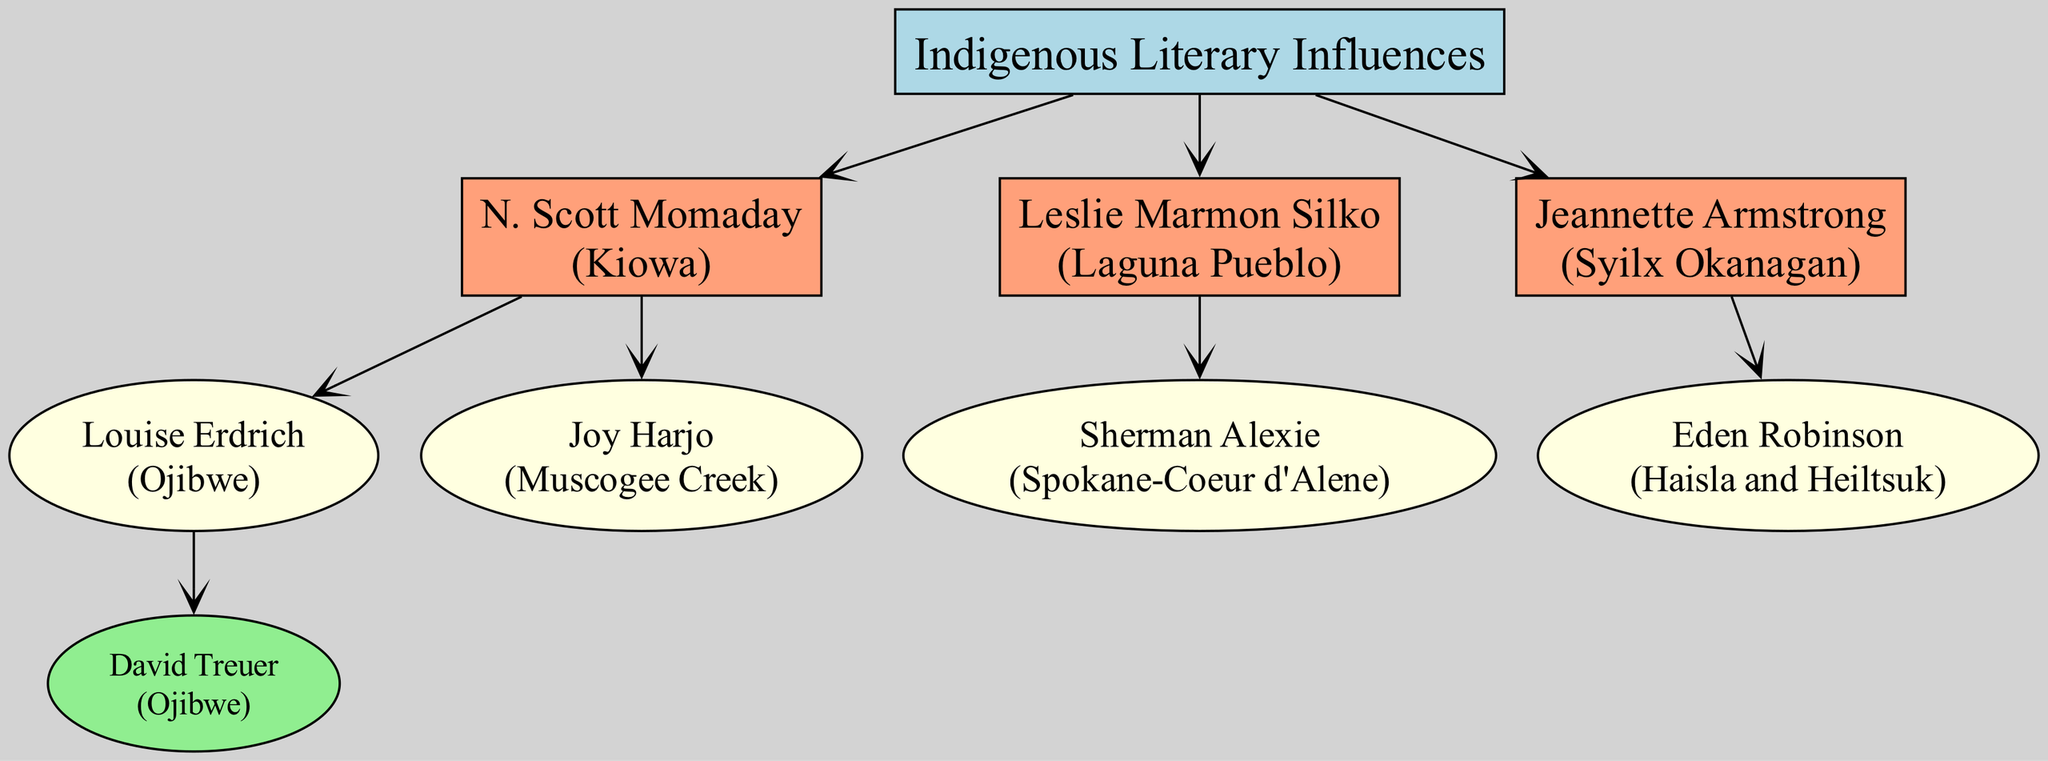What is the nationality of N. Scott Momaday? N. Scott Momaday is identified at the top of the diagram under the voice of "Indigenous Literary Influences"; his nationality is listed as Kiowa.
Answer: Kiowa How many literary mentees did N. Scott Momaday have? By observing the nodes branching from N. Scott Momaday, he has two mentees: Louise Erdrich and Joy Harjo.
Answer: 2 Who mentored Eden Robinson? Eden Robinson is a mentee of Jeannette Armstrong, whose node and exact relationships can be traced directly from the diagram.
Answer: Jeannette Armstrong Which indigenous author has the most documented mentees? Analyzing the branches from each author shown in the diagram reveals that N. Scott Momaday has the most mentees (two) compared to others who have only one.
Answer: N. Scott Momaday Which author has no recorded mentees according to the diagram? The diagram displays all noted authors and their mentees; Jeannette Armstrong's mentee is Eden Robinson, while other authors like Joy Harjo have no further mentees listed.
Answer: Joy Harjo What nationality is Sherman Alexie? From the diagram, Sherman Alexie is clearly identified, and his nationality is specified directly as Spokane-Coeur d'Alene.
Answer: Spokane-Coeur d'Alene How many levels of mentorship does the diagram display? The diagram highlights three distinct levels of mentorship: the root node, the first set of authors, and their respective mentees, making for a total of three levels.
Answer: 3 Who is the root of the family tree? The root node, which serves as the starting point of the family tree, is labeled "Indigenous Literary Influences."
Answer: Indigenous Literary Influences What is the relationship between Louise Erdrich and David Treuer? Louise Erdrich is identified as a mentee of N. Scott Momaday, while David Treuer is a mentee of Louise Erdrich, indicating a mentor-mentee relationship at two levels.
Answer: Mentor-Mentee 